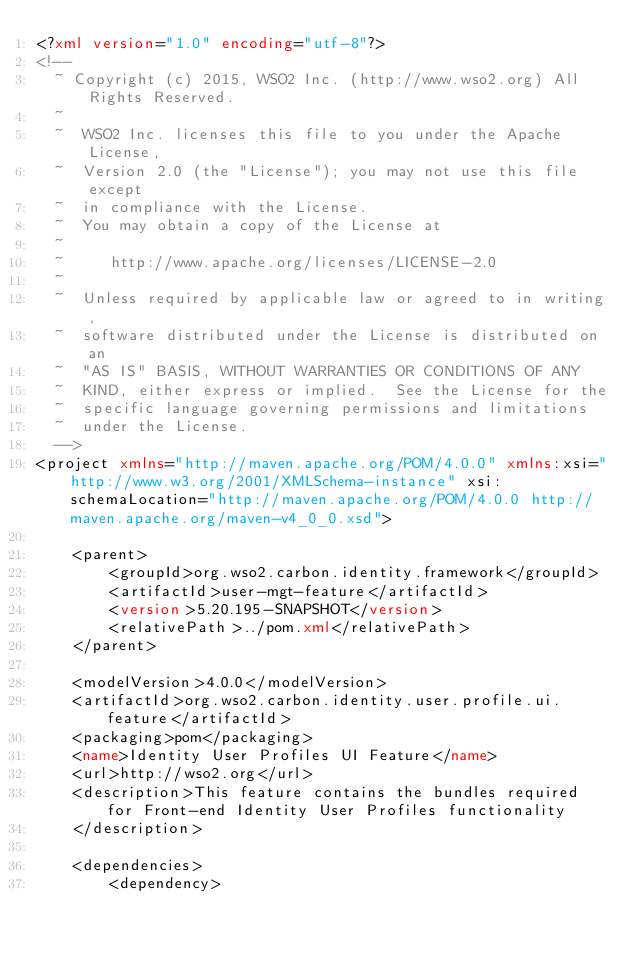<code> <loc_0><loc_0><loc_500><loc_500><_XML_><?xml version="1.0" encoding="utf-8"?>
<!--
  ~ Copyright (c) 2015, WSO2 Inc. (http://www.wso2.org) All Rights Reserved.
  ~
  ~  WSO2 Inc. licenses this file to you under the Apache License,
  ~  Version 2.0 (the "License"); you may not use this file except
  ~  in compliance with the License.
  ~  You may obtain a copy of the License at
  ~
  ~     http://www.apache.org/licenses/LICENSE-2.0
  ~
  ~  Unless required by applicable law or agreed to in writing,
  ~  software distributed under the License is distributed on an
  ~  "AS IS" BASIS, WITHOUT WARRANTIES OR CONDITIONS OF ANY
  ~  KIND, either express or implied.  See the License for the
  ~  specific language governing permissions and limitations
  ~  under the License.
  -->
<project xmlns="http://maven.apache.org/POM/4.0.0" xmlns:xsi="http://www.w3.org/2001/XMLSchema-instance" xsi:schemaLocation="http://maven.apache.org/POM/4.0.0 http://maven.apache.org/maven-v4_0_0.xsd">

    <parent>
        <groupId>org.wso2.carbon.identity.framework</groupId>
        <artifactId>user-mgt-feature</artifactId>
        <version>5.20.195-SNAPSHOT</version>
        <relativePath>../pom.xml</relativePath>
    </parent>

    <modelVersion>4.0.0</modelVersion>
    <artifactId>org.wso2.carbon.identity.user.profile.ui.feature</artifactId>
    <packaging>pom</packaging>
    <name>Identity User Profiles UI Feature</name>
    <url>http://wso2.org</url>
    <description>This feature contains the bundles required for Front-end Identity User Profiles functionality
    </description>

    <dependencies>
        <dependency></code> 